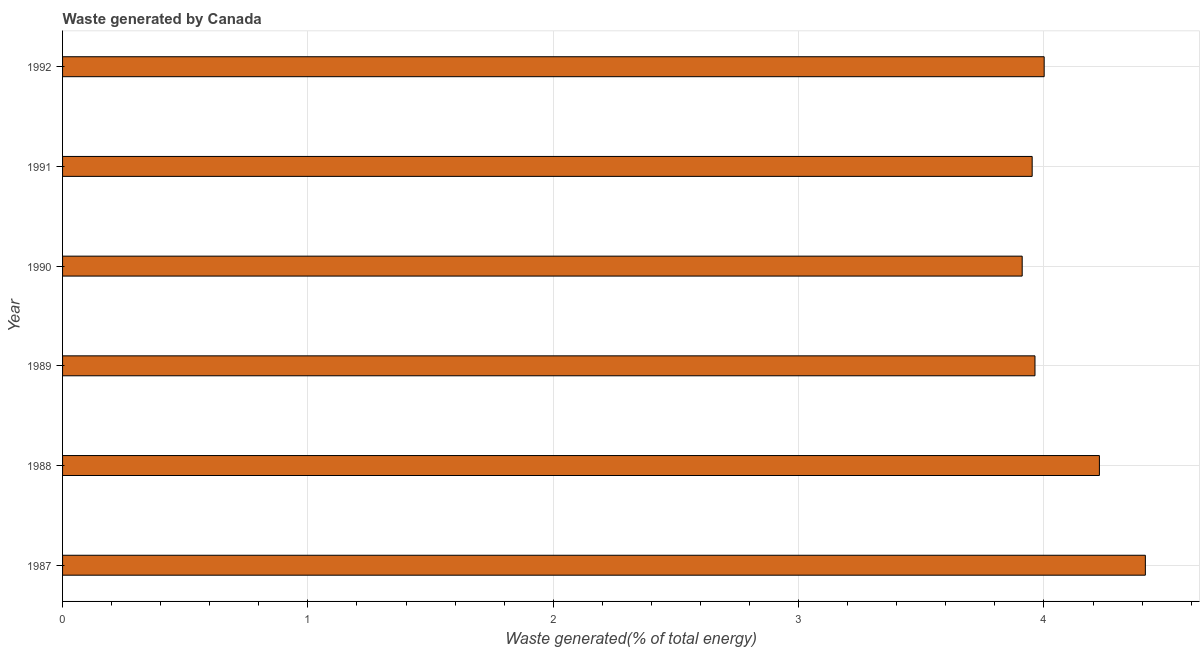Does the graph contain grids?
Offer a very short reply. Yes. What is the title of the graph?
Offer a terse response. Waste generated by Canada. What is the label or title of the X-axis?
Offer a very short reply. Waste generated(% of total energy). What is the amount of waste generated in 1991?
Keep it short and to the point. 3.95. Across all years, what is the maximum amount of waste generated?
Give a very brief answer. 4.41. Across all years, what is the minimum amount of waste generated?
Your answer should be compact. 3.91. In which year was the amount of waste generated maximum?
Keep it short and to the point. 1987. What is the sum of the amount of waste generated?
Keep it short and to the point. 24.47. What is the difference between the amount of waste generated in 1987 and 1989?
Offer a very short reply. 0.45. What is the average amount of waste generated per year?
Provide a succinct answer. 4.08. What is the median amount of waste generated?
Your response must be concise. 3.98. What is the ratio of the amount of waste generated in 1989 to that in 1990?
Your answer should be compact. 1.01. Is the amount of waste generated in 1988 less than that in 1991?
Provide a short and direct response. No. What is the difference between the highest and the second highest amount of waste generated?
Your answer should be very brief. 0.19. How many bars are there?
Give a very brief answer. 6. What is the difference between two consecutive major ticks on the X-axis?
Provide a succinct answer. 1. Are the values on the major ticks of X-axis written in scientific E-notation?
Your response must be concise. No. What is the Waste generated(% of total energy) in 1987?
Keep it short and to the point. 4.41. What is the Waste generated(% of total energy) of 1988?
Make the answer very short. 4.23. What is the Waste generated(% of total energy) of 1989?
Provide a succinct answer. 3.96. What is the Waste generated(% of total energy) of 1990?
Your answer should be compact. 3.91. What is the Waste generated(% of total energy) of 1991?
Provide a succinct answer. 3.95. What is the Waste generated(% of total energy) in 1992?
Offer a terse response. 4. What is the difference between the Waste generated(% of total energy) in 1987 and 1988?
Make the answer very short. 0.19. What is the difference between the Waste generated(% of total energy) in 1987 and 1989?
Offer a terse response. 0.45. What is the difference between the Waste generated(% of total energy) in 1987 and 1990?
Provide a succinct answer. 0.5. What is the difference between the Waste generated(% of total energy) in 1987 and 1991?
Keep it short and to the point. 0.46. What is the difference between the Waste generated(% of total energy) in 1987 and 1992?
Your answer should be compact. 0.41. What is the difference between the Waste generated(% of total energy) in 1988 and 1989?
Your answer should be very brief. 0.26. What is the difference between the Waste generated(% of total energy) in 1988 and 1990?
Your response must be concise. 0.31. What is the difference between the Waste generated(% of total energy) in 1988 and 1991?
Offer a terse response. 0.27. What is the difference between the Waste generated(% of total energy) in 1988 and 1992?
Your response must be concise. 0.23. What is the difference between the Waste generated(% of total energy) in 1989 and 1990?
Offer a terse response. 0.05. What is the difference between the Waste generated(% of total energy) in 1989 and 1991?
Give a very brief answer. 0.01. What is the difference between the Waste generated(% of total energy) in 1989 and 1992?
Provide a short and direct response. -0.04. What is the difference between the Waste generated(% of total energy) in 1990 and 1991?
Offer a very short reply. -0.04. What is the difference between the Waste generated(% of total energy) in 1990 and 1992?
Your answer should be very brief. -0.09. What is the difference between the Waste generated(% of total energy) in 1991 and 1992?
Provide a succinct answer. -0.05. What is the ratio of the Waste generated(% of total energy) in 1987 to that in 1988?
Your answer should be compact. 1.04. What is the ratio of the Waste generated(% of total energy) in 1987 to that in 1989?
Offer a very short reply. 1.11. What is the ratio of the Waste generated(% of total energy) in 1987 to that in 1990?
Provide a short and direct response. 1.13. What is the ratio of the Waste generated(% of total energy) in 1987 to that in 1991?
Ensure brevity in your answer.  1.12. What is the ratio of the Waste generated(% of total energy) in 1987 to that in 1992?
Your answer should be very brief. 1.1. What is the ratio of the Waste generated(% of total energy) in 1988 to that in 1989?
Your response must be concise. 1.07. What is the ratio of the Waste generated(% of total energy) in 1988 to that in 1990?
Make the answer very short. 1.08. What is the ratio of the Waste generated(% of total energy) in 1988 to that in 1991?
Provide a succinct answer. 1.07. What is the ratio of the Waste generated(% of total energy) in 1988 to that in 1992?
Give a very brief answer. 1.06. What is the ratio of the Waste generated(% of total energy) in 1989 to that in 1990?
Make the answer very short. 1.01. What is the ratio of the Waste generated(% of total energy) in 1989 to that in 1991?
Provide a short and direct response. 1. What is the ratio of the Waste generated(% of total energy) in 1989 to that in 1992?
Offer a very short reply. 0.99. What is the ratio of the Waste generated(% of total energy) in 1990 to that in 1992?
Provide a short and direct response. 0.98. 